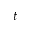<formula> <loc_0><loc_0><loc_500><loc_500>t</formula> 